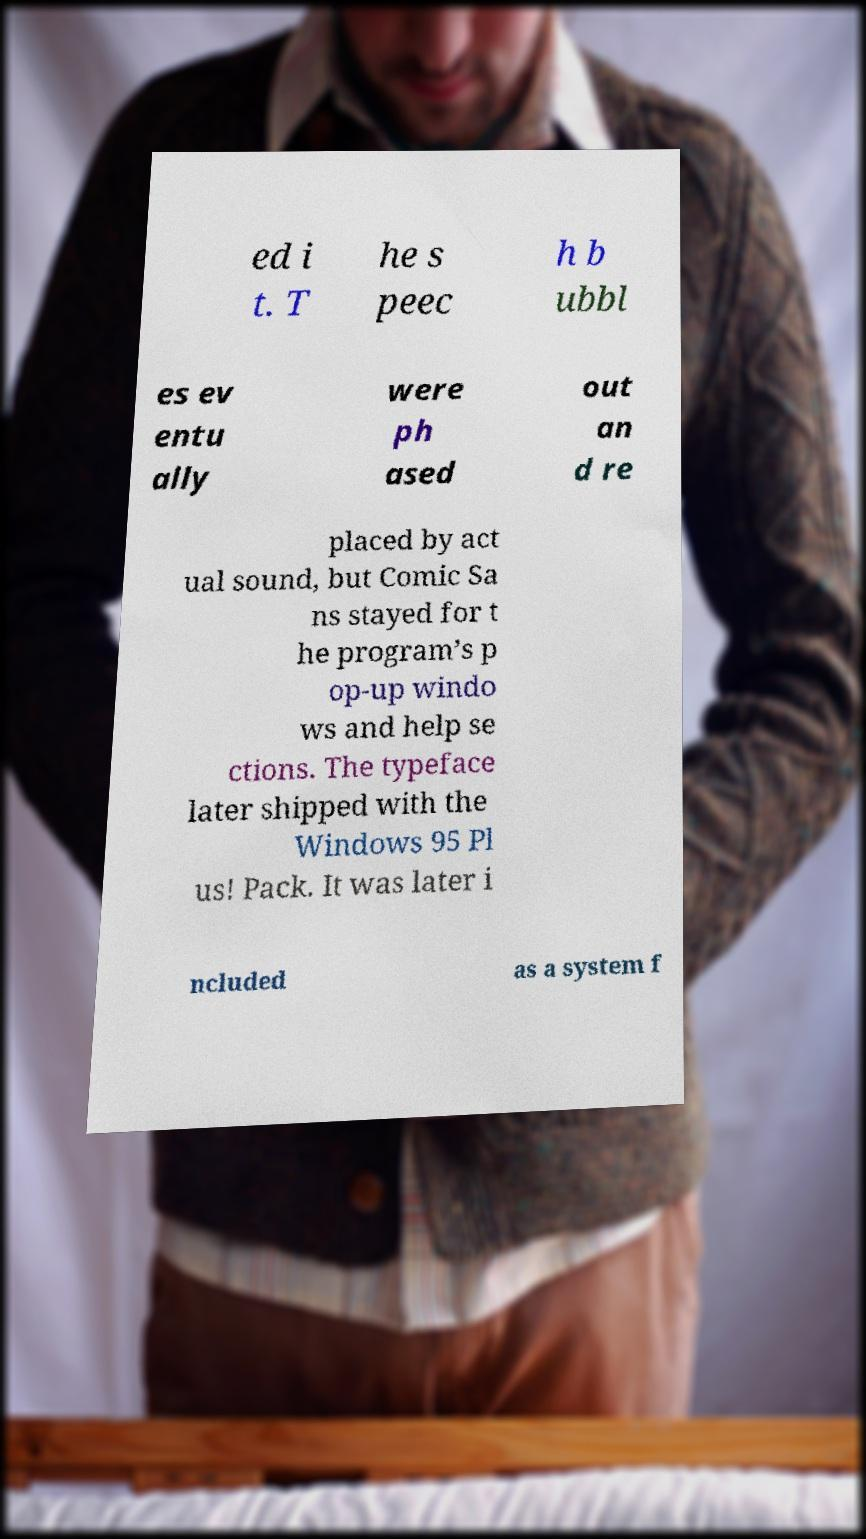Could you assist in decoding the text presented in this image and type it out clearly? ed i t. T he s peec h b ubbl es ev entu ally were ph ased out an d re placed by act ual sound, but Comic Sa ns stayed for t he program’s p op-up windo ws and help se ctions. The typeface later shipped with the Windows 95 Pl us! Pack. It was later i ncluded as a system f 